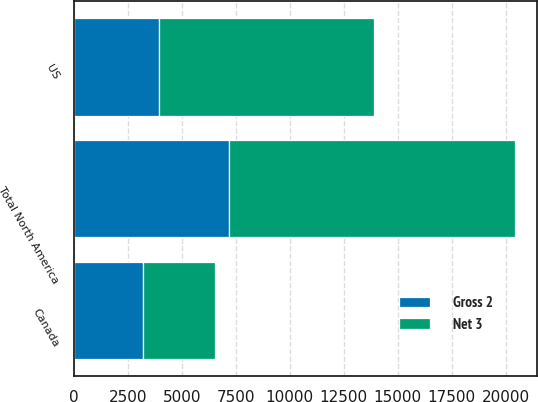Convert chart. <chart><loc_0><loc_0><loc_500><loc_500><stacked_bar_chart><ecel><fcel>US<fcel>Canada<fcel>Total North America<nl><fcel>Net 3<fcel>9927<fcel>3321<fcel>13248<nl><fcel>Gross 2<fcel>3963<fcel>3202<fcel>7165<nl></chart> 